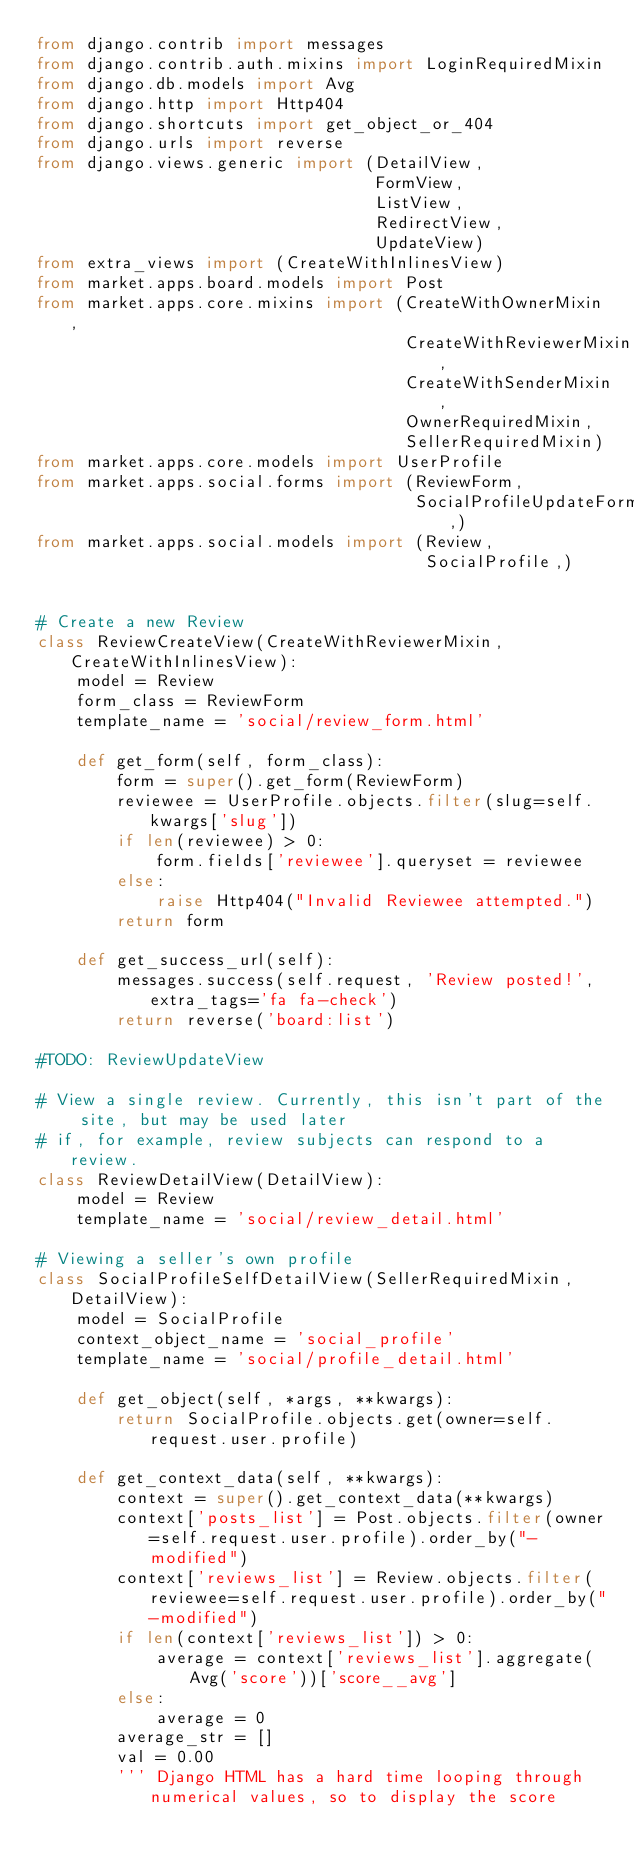Convert code to text. <code><loc_0><loc_0><loc_500><loc_500><_Python_>from django.contrib import messages
from django.contrib.auth.mixins import LoginRequiredMixin
from django.db.models import Avg
from django.http import Http404
from django.shortcuts import get_object_or_404
from django.urls import reverse
from django.views.generic import (DetailView,
                                  FormView,
                                  ListView,
                                  RedirectView,
                                  UpdateView)
from extra_views import (CreateWithInlinesView)
from market.apps.board.models import Post
from market.apps.core.mixins import (CreateWithOwnerMixin,
                                     CreateWithReviewerMixin,
                                     CreateWithSenderMixin,
                                     OwnerRequiredMixin,
                                     SellerRequiredMixin)
from market.apps.core.models import UserProfile
from market.apps.social.forms import (ReviewForm,
                                      SocialProfileUpdateForm,)
from market.apps.social.models import (Review,
                                       SocialProfile,)


# Create a new Review
class ReviewCreateView(CreateWithReviewerMixin, CreateWithInlinesView):
    model = Review
    form_class = ReviewForm
    template_name = 'social/review_form.html'

    def get_form(self, form_class):
        form = super().get_form(ReviewForm)
        reviewee = UserProfile.objects.filter(slug=self.kwargs['slug'])
        if len(reviewee) > 0:
            form.fields['reviewee'].queryset = reviewee
        else:
            raise Http404("Invalid Reviewee attempted.")
        return form

    def get_success_url(self):
        messages.success(self.request, 'Review posted!', extra_tags='fa fa-check')
        return reverse('board:list')

#TODO: ReviewUpdateView

# View a single review. Currently, this isn't part of the site, but may be used later
# if, for example, review subjects can respond to a review.
class ReviewDetailView(DetailView):
    model = Review
    template_name = 'social/review_detail.html'

# Viewing a seller's own profile
class SocialProfileSelfDetailView(SellerRequiredMixin, DetailView):
    model = SocialProfile
    context_object_name = 'social_profile'
    template_name = 'social/profile_detail.html'

    def get_object(self, *args, **kwargs):
        return SocialProfile.objects.get(owner=self.request.user.profile)

    def get_context_data(self, **kwargs):
        context = super().get_context_data(**kwargs)
        context['posts_list'] = Post.objects.filter(owner=self.request.user.profile).order_by("-modified")
        context['reviews_list'] = Review.objects.filter(reviewee=self.request.user.profile).order_by("-modified")
        if len(context['reviews_list']) > 0:
            average = context['reviews_list'].aggregate(Avg('score'))['score__avg']
        else:
            average = 0
        average_str = []
        val = 0.00
        ''' Django HTML has a hard time looping through numerical values, so to display the score</code> 